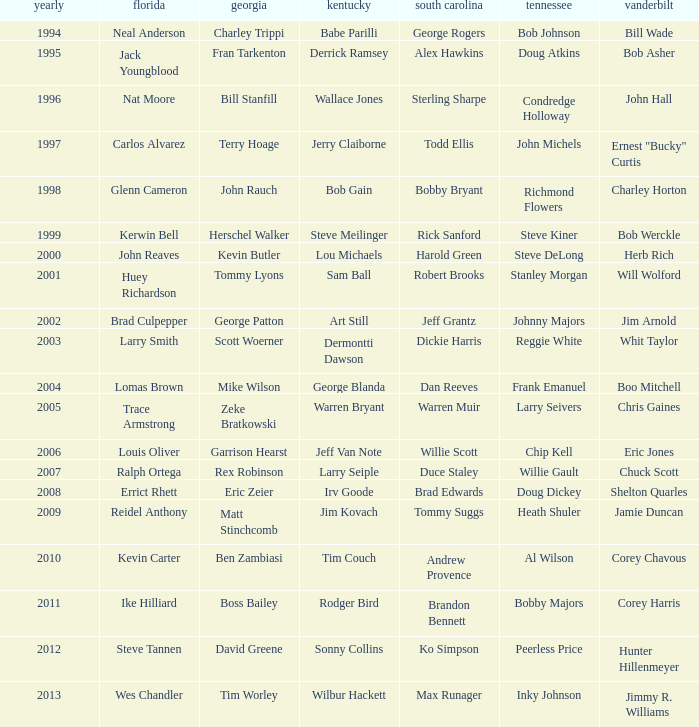What is the Tennessee that Georgia of kevin butler is in? Steve DeLong. 